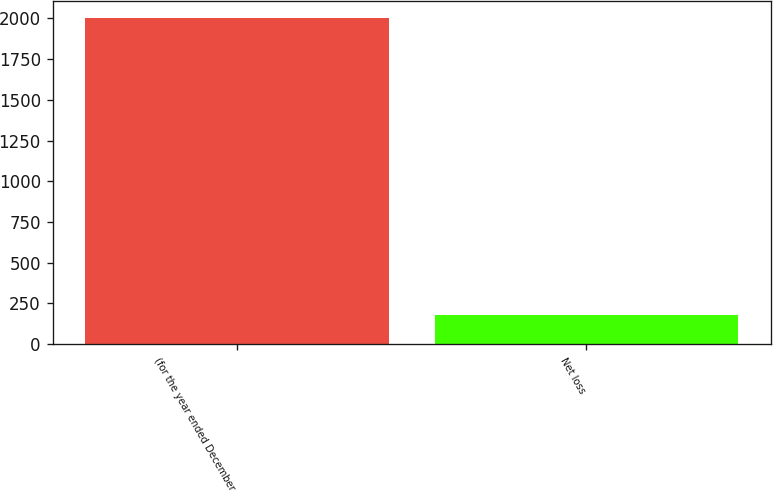Convert chart. <chart><loc_0><loc_0><loc_500><loc_500><bar_chart><fcel>(for the year ended December<fcel>Net loss<nl><fcel>2004<fcel>182<nl></chart> 